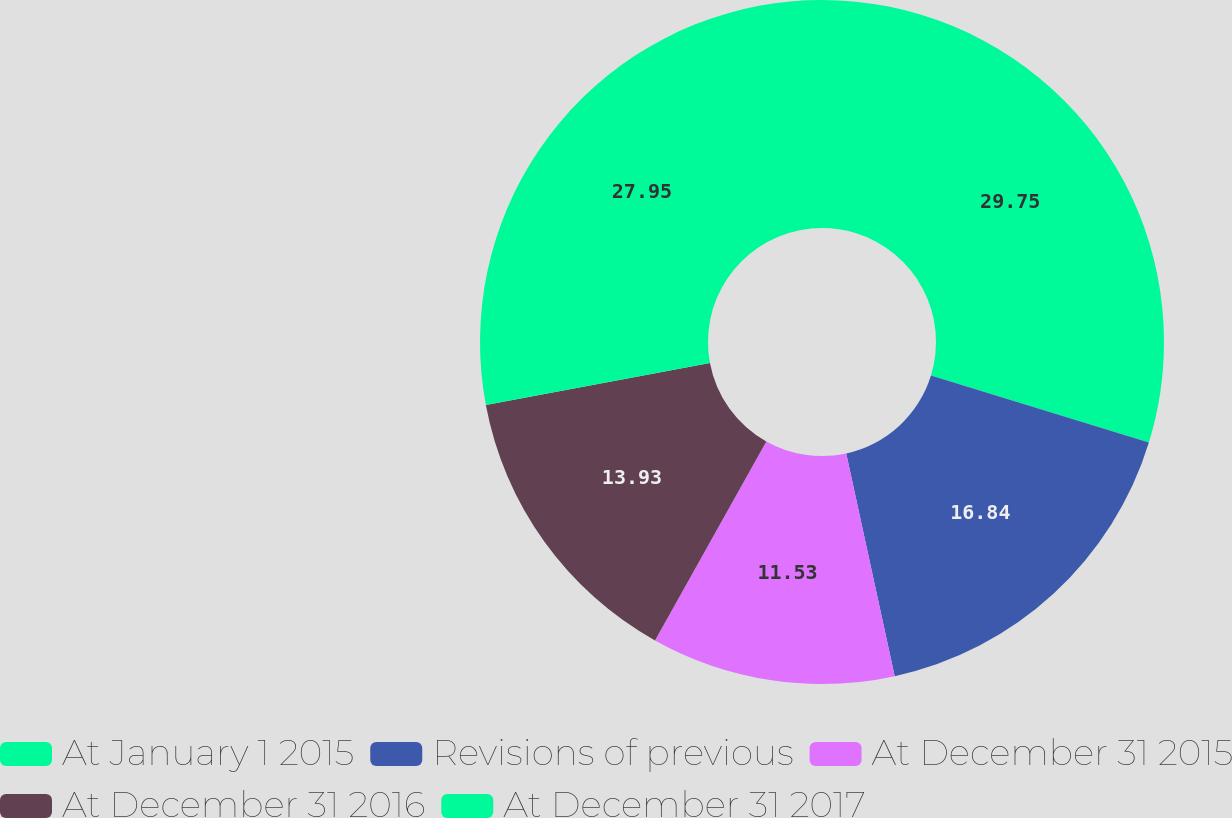Convert chart to OTSL. <chart><loc_0><loc_0><loc_500><loc_500><pie_chart><fcel>At January 1 2015<fcel>Revisions of previous<fcel>At December 31 2015<fcel>At December 31 2016<fcel>At December 31 2017<nl><fcel>29.75%<fcel>16.84%<fcel>11.53%<fcel>13.93%<fcel>27.95%<nl></chart> 